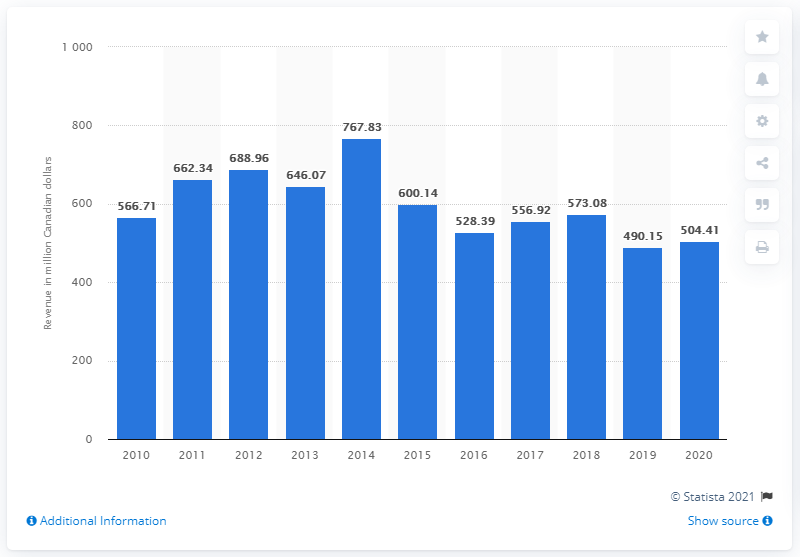Outline some significant characteristics in this image. In 2019, CBC/Radio-Canada's revenue was 490.15 million dollars. In 2020, CBC/Radio-Canada generated a total revenue of 504.41 million Canadian dollars. CBC/Radio-Canada has not reported the total revenue it has generated since 2016, which is approximately 600.14. 